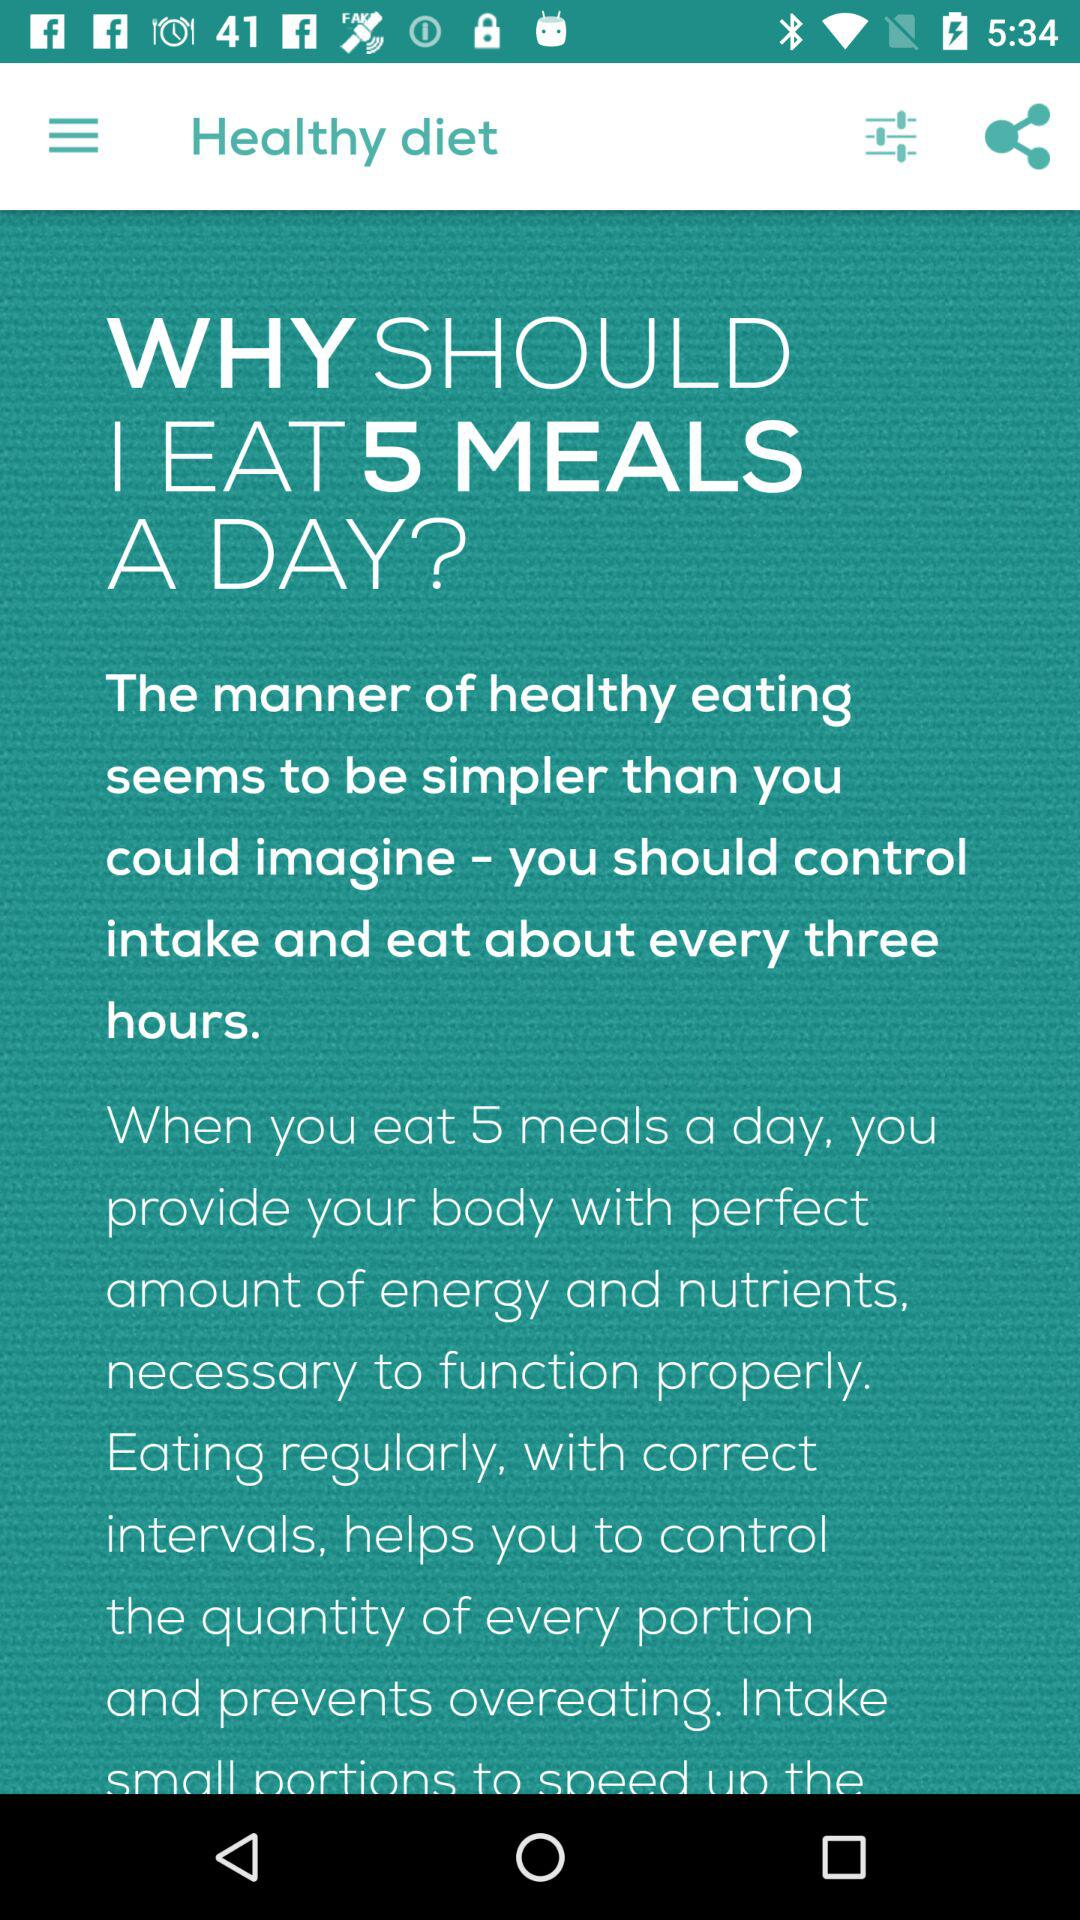What to eat to be healthy? To be healthy, eat 5 meals a day. 